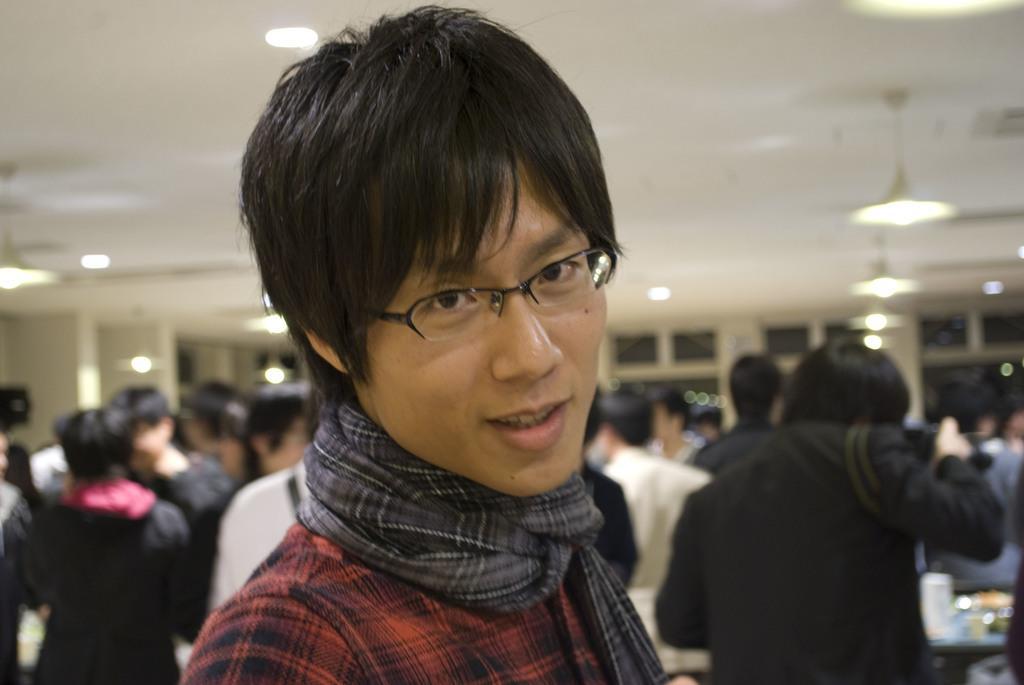How would you summarize this image in a sentence or two? In this picture there is a man in the center of the image and there are other people behind him, there are lamps and windows in the background area of the image. 